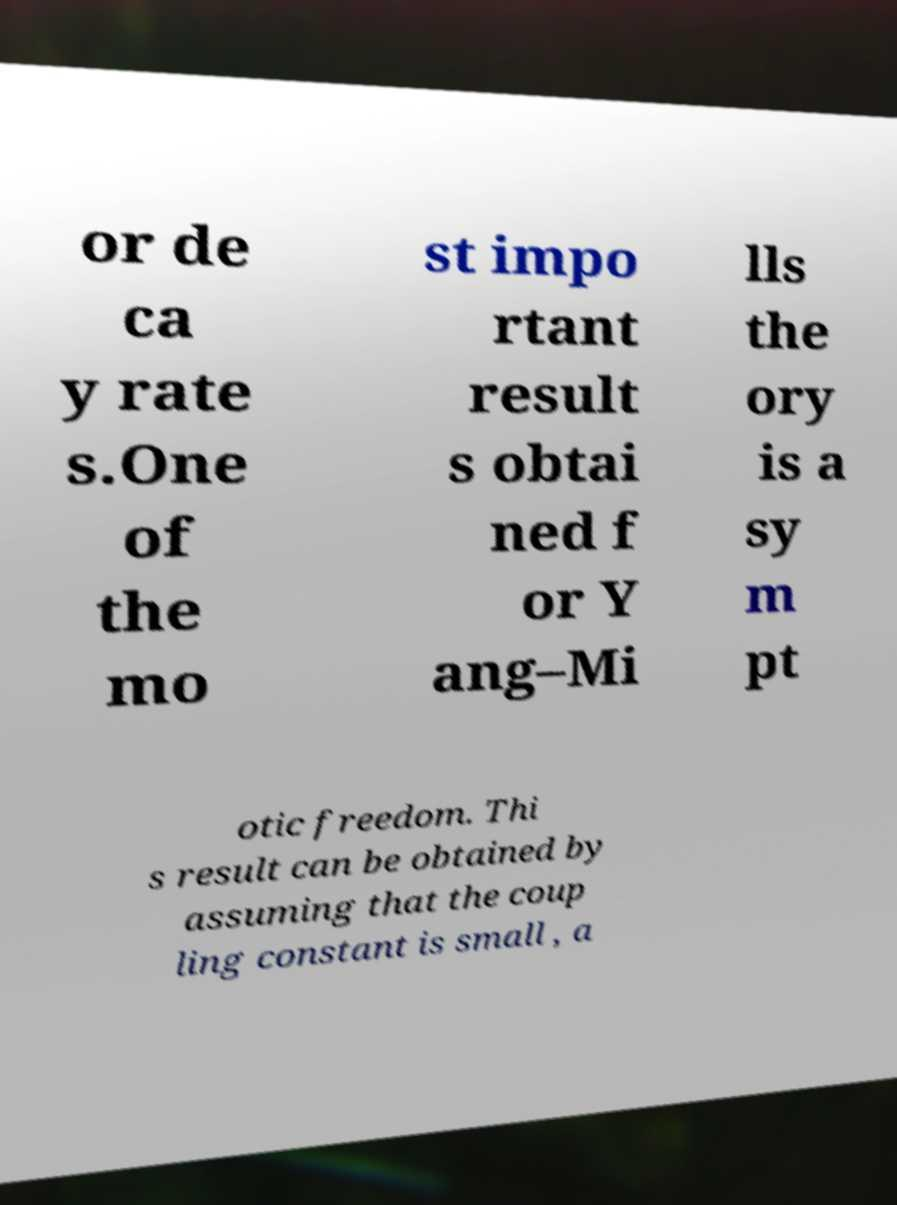I need the written content from this picture converted into text. Can you do that? or de ca y rate s.One of the mo st impo rtant result s obtai ned f or Y ang–Mi lls the ory is a sy m pt otic freedom. Thi s result can be obtained by assuming that the coup ling constant is small , a 